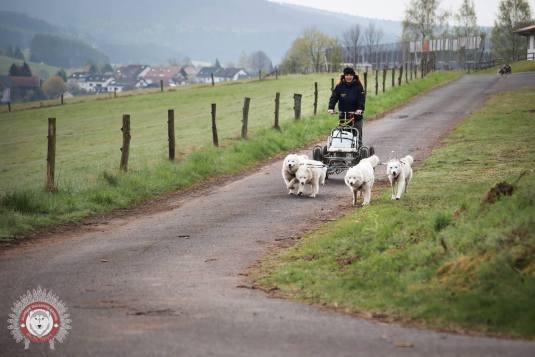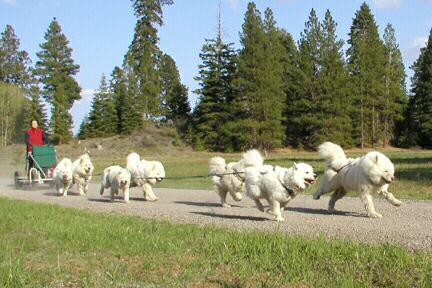The first image is the image on the left, the second image is the image on the right. For the images shown, is this caption "At least one image shows a person in a vehicle behind at least one dog, going down a lane." true? Answer yes or no. Yes. The first image is the image on the left, the second image is the image on the right. Assess this claim about the two images: "In one image, a woman is shown with a white dog and three sheep.". Correct or not? Answer yes or no. No. 